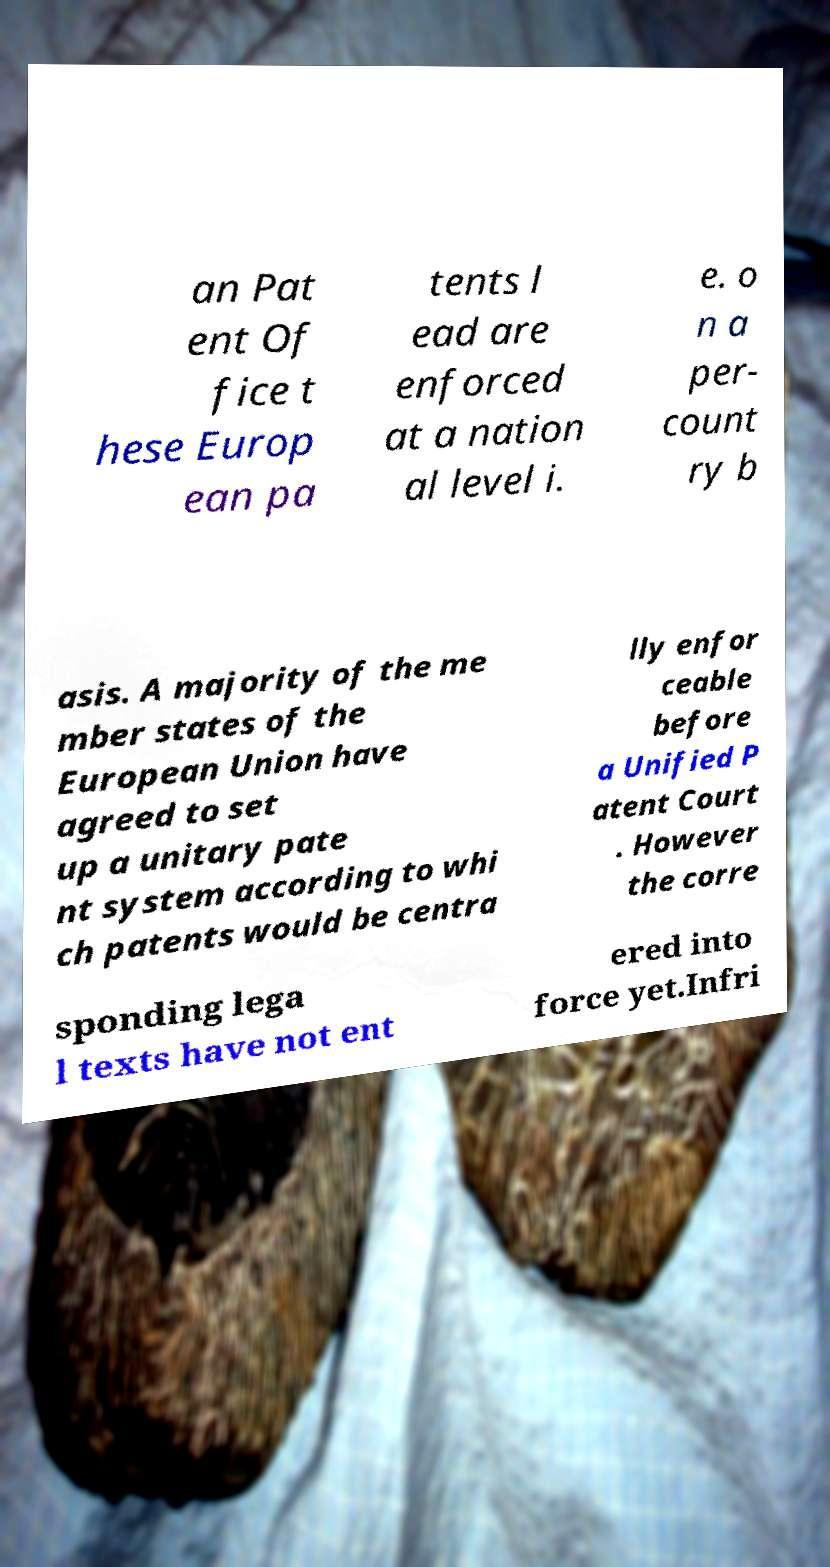Please identify and transcribe the text found in this image. an Pat ent Of fice t hese Europ ean pa tents l ead are enforced at a nation al level i. e. o n a per- count ry b asis. A majority of the me mber states of the European Union have agreed to set up a unitary pate nt system according to whi ch patents would be centra lly enfor ceable before a Unified P atent Court . However the corre sponding lega l texts have not ent ered into force yet.Infri 